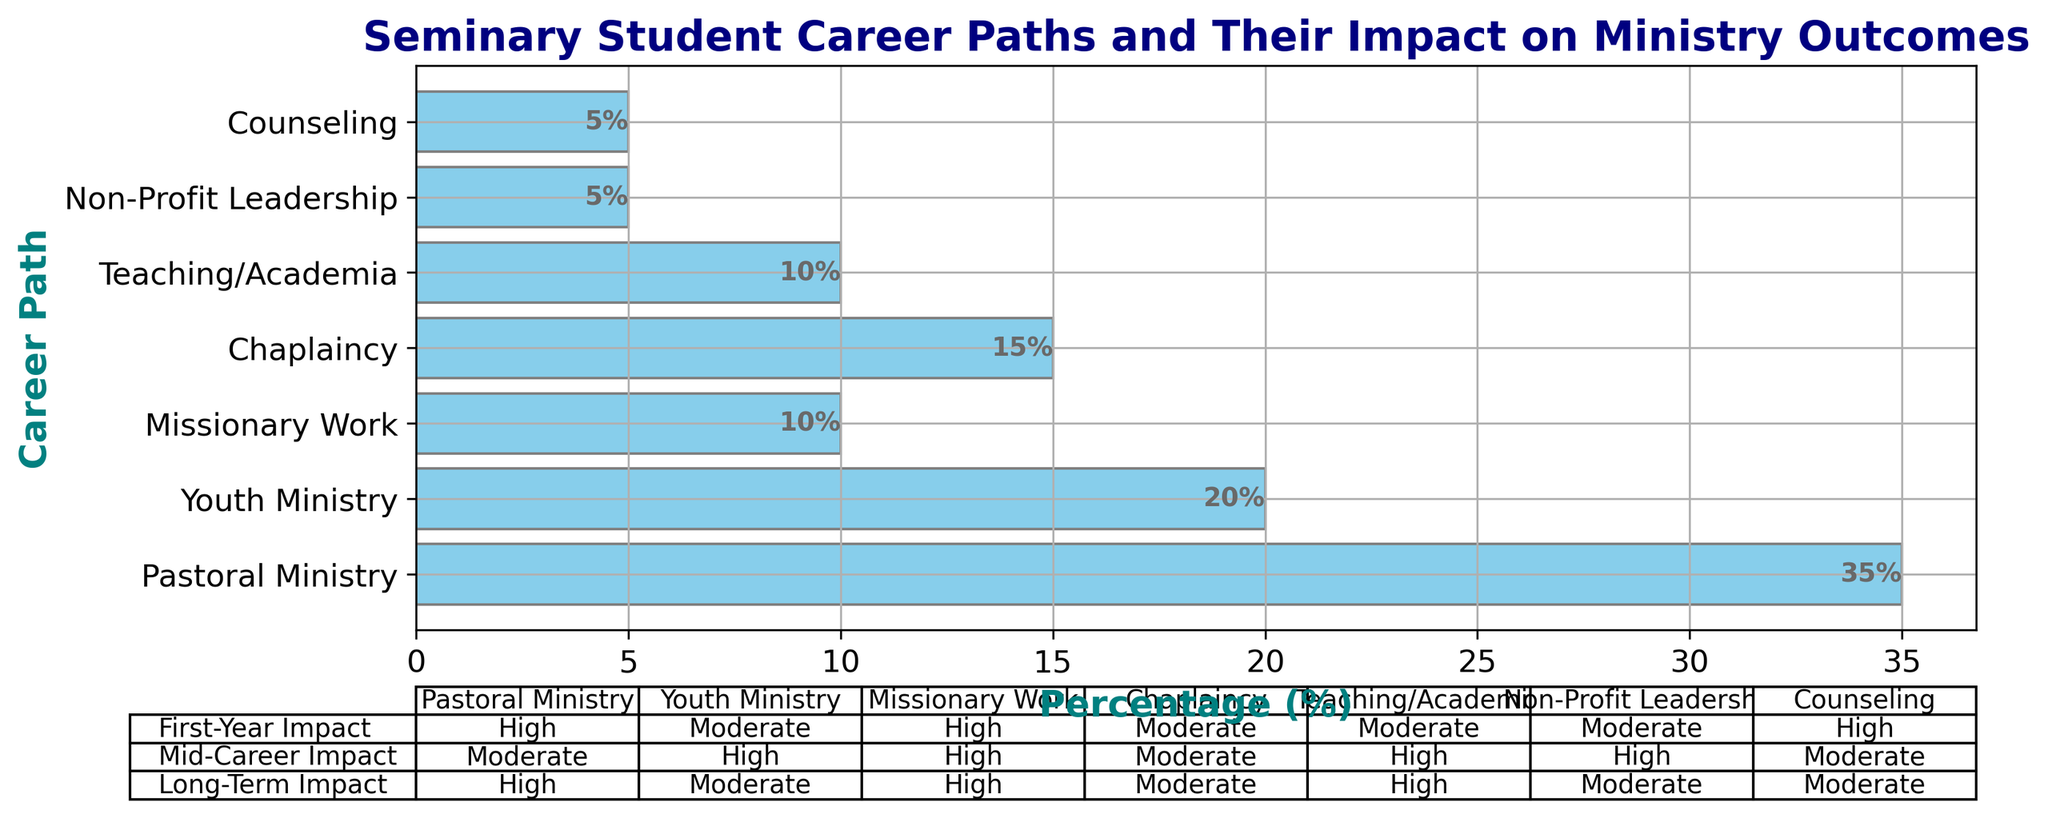What percentage of students are in Pastoral Ministry? Look at the bar representing "Pastoral Ministry" and read the percentage labeled next to it.
Answer: 35% What is the difference in percentage between students in Youth Ministry and Teaching/Academia? Youth Ministry accounts for 20%, and Teaching/Academia accounts for 10%. Subtract the percentages: 20% - 10% = 10%.
Answer: 10% Which career path has the highest percentage of students? Compare the heights of all the bars; the bar representing Pastoral Ministry is the highest.
Answer: Pastoral Ministry How does the Mid-Career Impact of Non-Profit Leadership compare to its First-Year Impact? In the table, Non-Profit Leadership is found in the respective columns: Mid-Career Impact is "High" while First-Year Impact is "Moderate."
Answer: Higher Which career paths have a High Long-Term Impact? In the Long-Term Impact row, locate all the columns marked "High": Pastoral Ministry, Missionary Work, and Teaching/Academia.
Answer: Pastoral Ministry, Missionary Work, Teaching/Academia What is the combined percentage of students pursuing Missionary Work and Counseling? Add the percentages of Missionary Work (10%) and Counseling (5%): 10% + 5% = 15%.
Answer: 15% For which career paths is the First-Year Impact rated as High? In the First-Year Impact row of the table, locate all the columns marked "High": Pastoral Ministry, Missionary Work, Counseling.
Answer: Pastoral Ministry, Missionary Work, Counseling Which career path has the lowest representation among seminary students? Compare the heights of all the bars; the shortest bar represents Non-Profit Leadership and Counseling, each at 5%.
Answer: Non-Profit Leadership, Counseling 